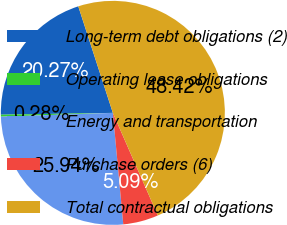Convert chart. <chart><loc_0><loc_0><loc_500><loc_500><pie_chart><fcel>Long-term debt obligations (2)<fcel>Operating lease obligations<fcel>Energy and transportation<fcel>Purchase orders (6)<fcel>Total contractual obligations<nl><fcel>20.27%<fcel>0.28%<fcel>25.94%<fcel>5.09%<fcel>48.42%<nl></chart> 